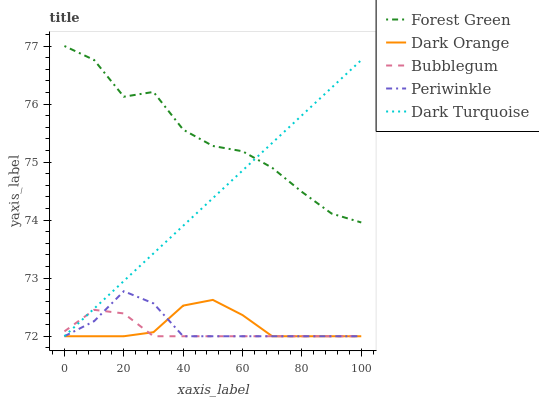Does Periwinkle have the minimum area under the curve?
Answer yes or no. No. Does Periwinkle have the maximum area under the curve?
Answer yes or no. No. Is Periwinkle the smoothest?
Answer yes or no. No. Is Periwinkle the roughest?
Answer yes or no. No. Does Forest Green have the lowest value?
Answer yes or no. No. Does Periwinkle have the highest value?
Answer yes or no. No. Is Bubblegum less than Forest Green?
Answer yes or no. Yes. Is Forest Green greater than Periwinkle?
Answer yes or no. Yes. Does Bubblegum intersect Forest Green?
Answer yes or no. No. 